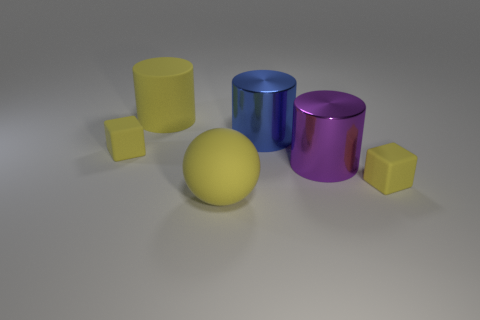Are there more big brown metal blocks than small objects?
Your answer should be compact. No. There is a matte ball that is the same color as the large rubber cylinder; what is its size?
Provide a succinct answer. Large. Are there any large brown cylinders that have the same material as the blue cylinder?
Your answer should be very brief. No. What shape is the yellow rubber thing that is on the right side of the yellow matte cylinder and behind the rubber ball?
Make the answer very short. Cube. What number of other objects are the same shape as the purple object?
Offer a very short reply. 2. The blue shiny cylinder has what size?
Your answer should be very brief. Large. What number of things are either purple shiny objects or blue shiny cubes?
Offer a very short reply. 1. There is a yellow rubber block that is on the right side of the purple cylinder; how big is it?
Provide a short and direct response. Small. Is there anything else that has the same size as the matte cylinder?
Your response must be concise. Yes. What color is the big object that is in front of the big yellow rubber cylinder and behind the purple thing?
Give a very brief answer. Blue. 